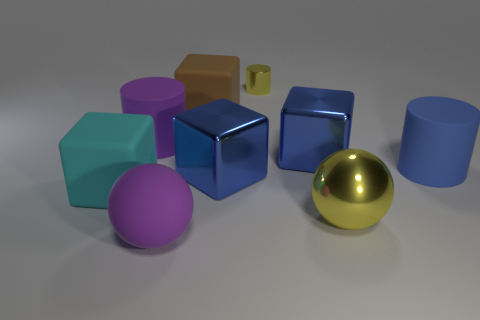Add 1 purple cylinders. How many objects exist? 10 Subtract all cubes. How many objects are left? 5 Add 5 large brown cubes. How many large brown cubes exist? 6 Subtract 0 red balls. How many objects are left? 9 Subtract all big brown objects. Subtract all large blue shiny cubes. How many objects are left? 6 Add 2 purple objects. How many purple objects are left? 4 